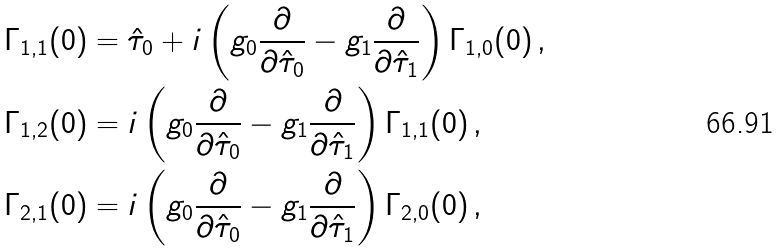Convert formula to latex. <formula><loc_0><loc_0><loc_500><loc_500>\Gamma _ { 1 , 1 } ( { 0 } ) & = \hat { \tau } _ { 0 } + i \left ( g _ { 0 } \frac { \partial } { \partial \hat { \tau } _ { 0 } } - g _ { 1 } \frac { \partial } { \partial \hat { \tau } _ { 1 } } \right ) \Gamma _ { 1 , 0 } ( { 0 } ) \, , \\ \Gamma _ { 1 , 2 } ( { 0 } ) & = i \left ( g _ { 0 } \frac { \partial } { \partial \hat { \tau } _ { 0 } } - g _ { 1 } \frac { \partial } { \partial \hat { \tau } _ { 1 } } \right ) \Gamma _ { 1 , 1 } ( { 0 } ) \, , \\ \Gamma _ { 2 , 1 } ( { 0 } ) & = i \left ( g _ { 0 } \frac { \partial } { \partial \hat { \tau } _ { 0 } } - g _ { 1 } \frac { \partial } { \partial \hat { \tau } _ { 1 } } \right ) \Gamma _ { 2 , 0 } ( { 0 } ) \, ,</formula> 